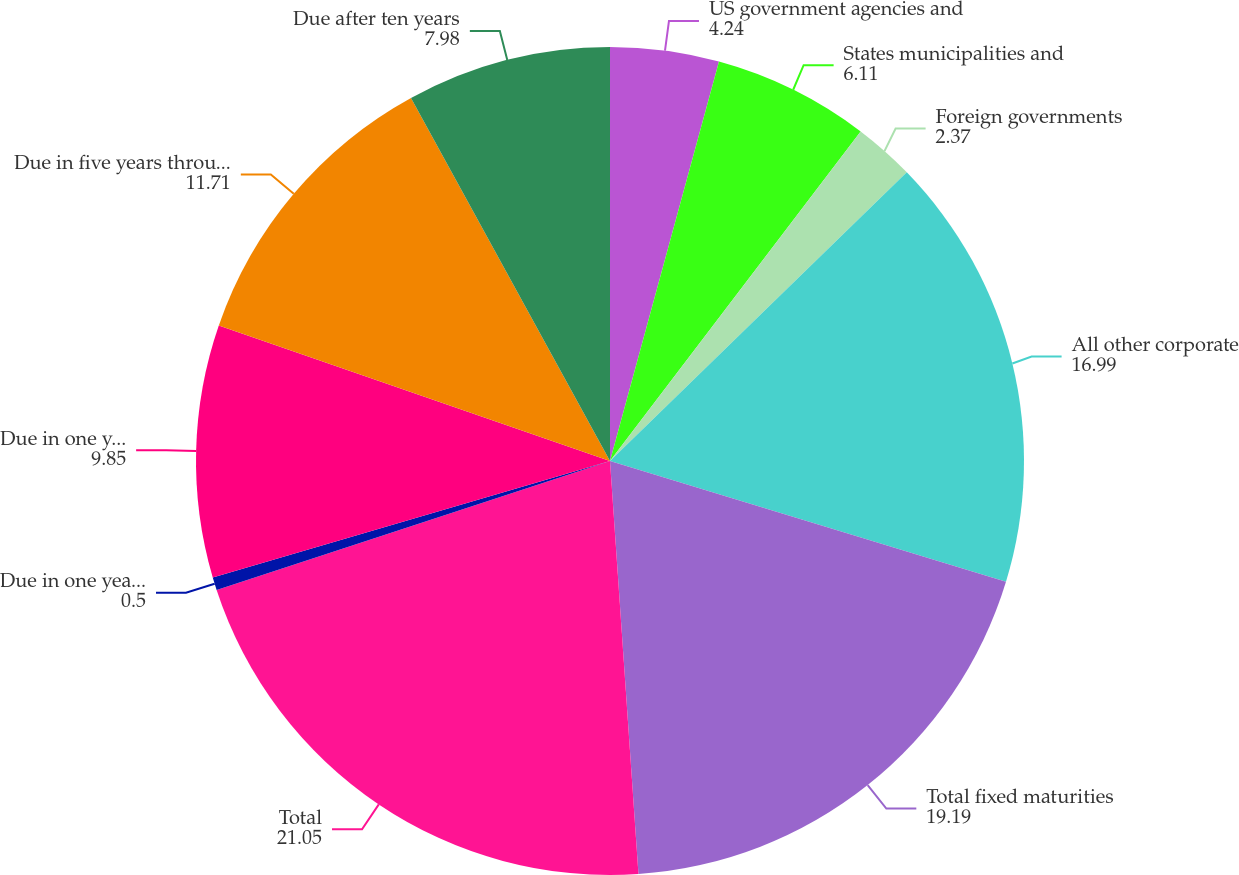Convert chart to OTSL. <chart><loc_0><loc_0><loc_500><loc_500><pie_chart><fcel>US government agencies and<fcel>States municipalities and<fcel>Foreign governments<fcel>All other corporate<fcel>Total fixed maturities<fcel>Total<fcel>Due in one year or less<fcel>Due in one year through five<fcel>Due in five years through ten<fcel>Due after ten years<nl><fcel>4.24%<fcel>6.11%<fcel>2.37%<fcel>16.99%<fcel>19.19%<fcel>21.05%<fcel>0.5%<fcel>9.85%<fcel>11.71%<fcel>7.98%<nl></chart> 